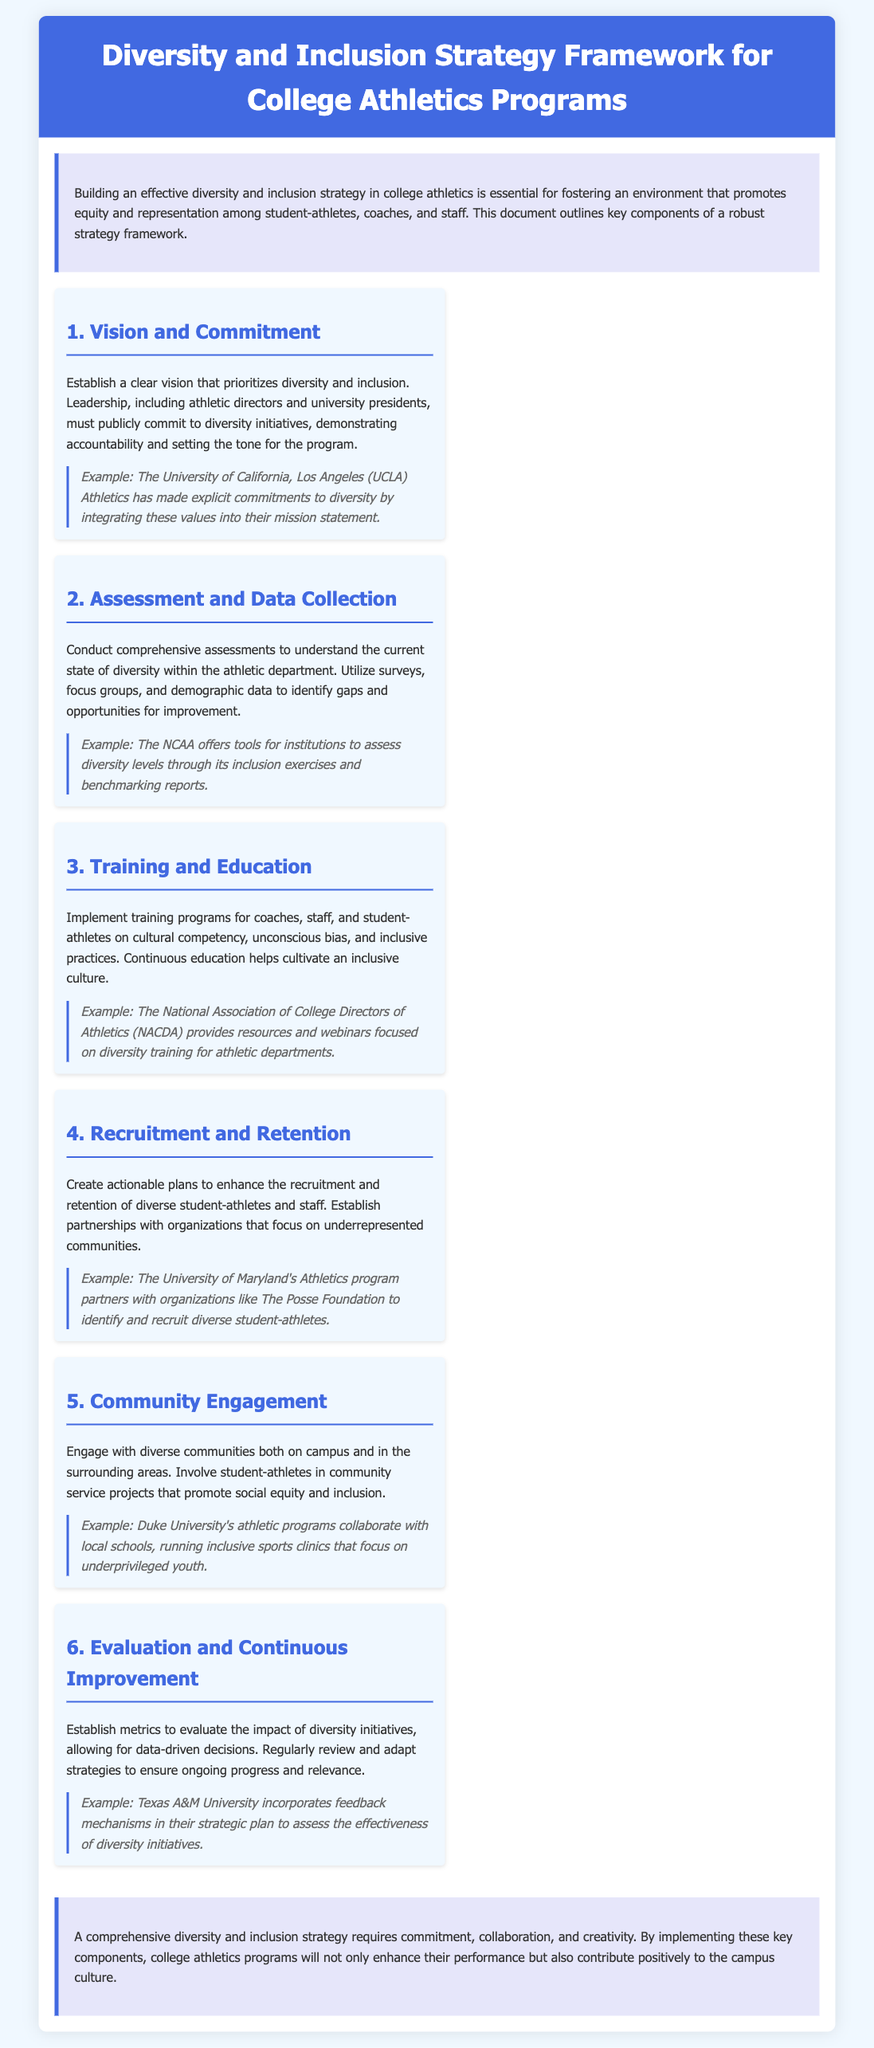What is the title of the document? The title of the document is found in the header section, which states the framework for the strategic approach discussed.
Answer: Diversity and Inclusion Strategy Framework for College Athletics Programs Who is responsible for the commitment to diversity initiatives? The document mentions that leadership, including athletic directors and university presidents, must publicly commit to diversity initiatives.
Answer: Leadership What is one method for assessing diversity in athletics? The document suggests utilizing surveys, focus groups, and demographic data to identify gaps and opportunities for improvement.
Answer: Surveys What training area is emphasized for coaches and staff? The document highlights cultural competency, unconscious bias, and inclusive practices as important training areas.
Answer: Cultural competency Which university partners with The Posse Foundation? The document provides an example of a university that has established partnerships to enhance diversity recruitment and retention.
Answer: University of Maryland How are community engagements characterized in the document? The document states that student-athletes are involved in community service projects that promote social equity and inclusion.
Answer: Community service projects What is the purpose of establishing metrics in diversity initiatives? The document explains that metrics are used to evaluate the impact of diversity initiatives for data-driven decisions.
Answer: Evaluate impact What organization provides resources and webinars for diversity training? The document cites the National Association of College Directors of Athletics as a resource for diversity training.
Answer: NACDA What component helps in continuous improvement of diversity strategies? The document mentions the need for regular reviews and adaptations of strategies to ensure ongoing progress.
Answer: Evaluation and Continuous Improvement 